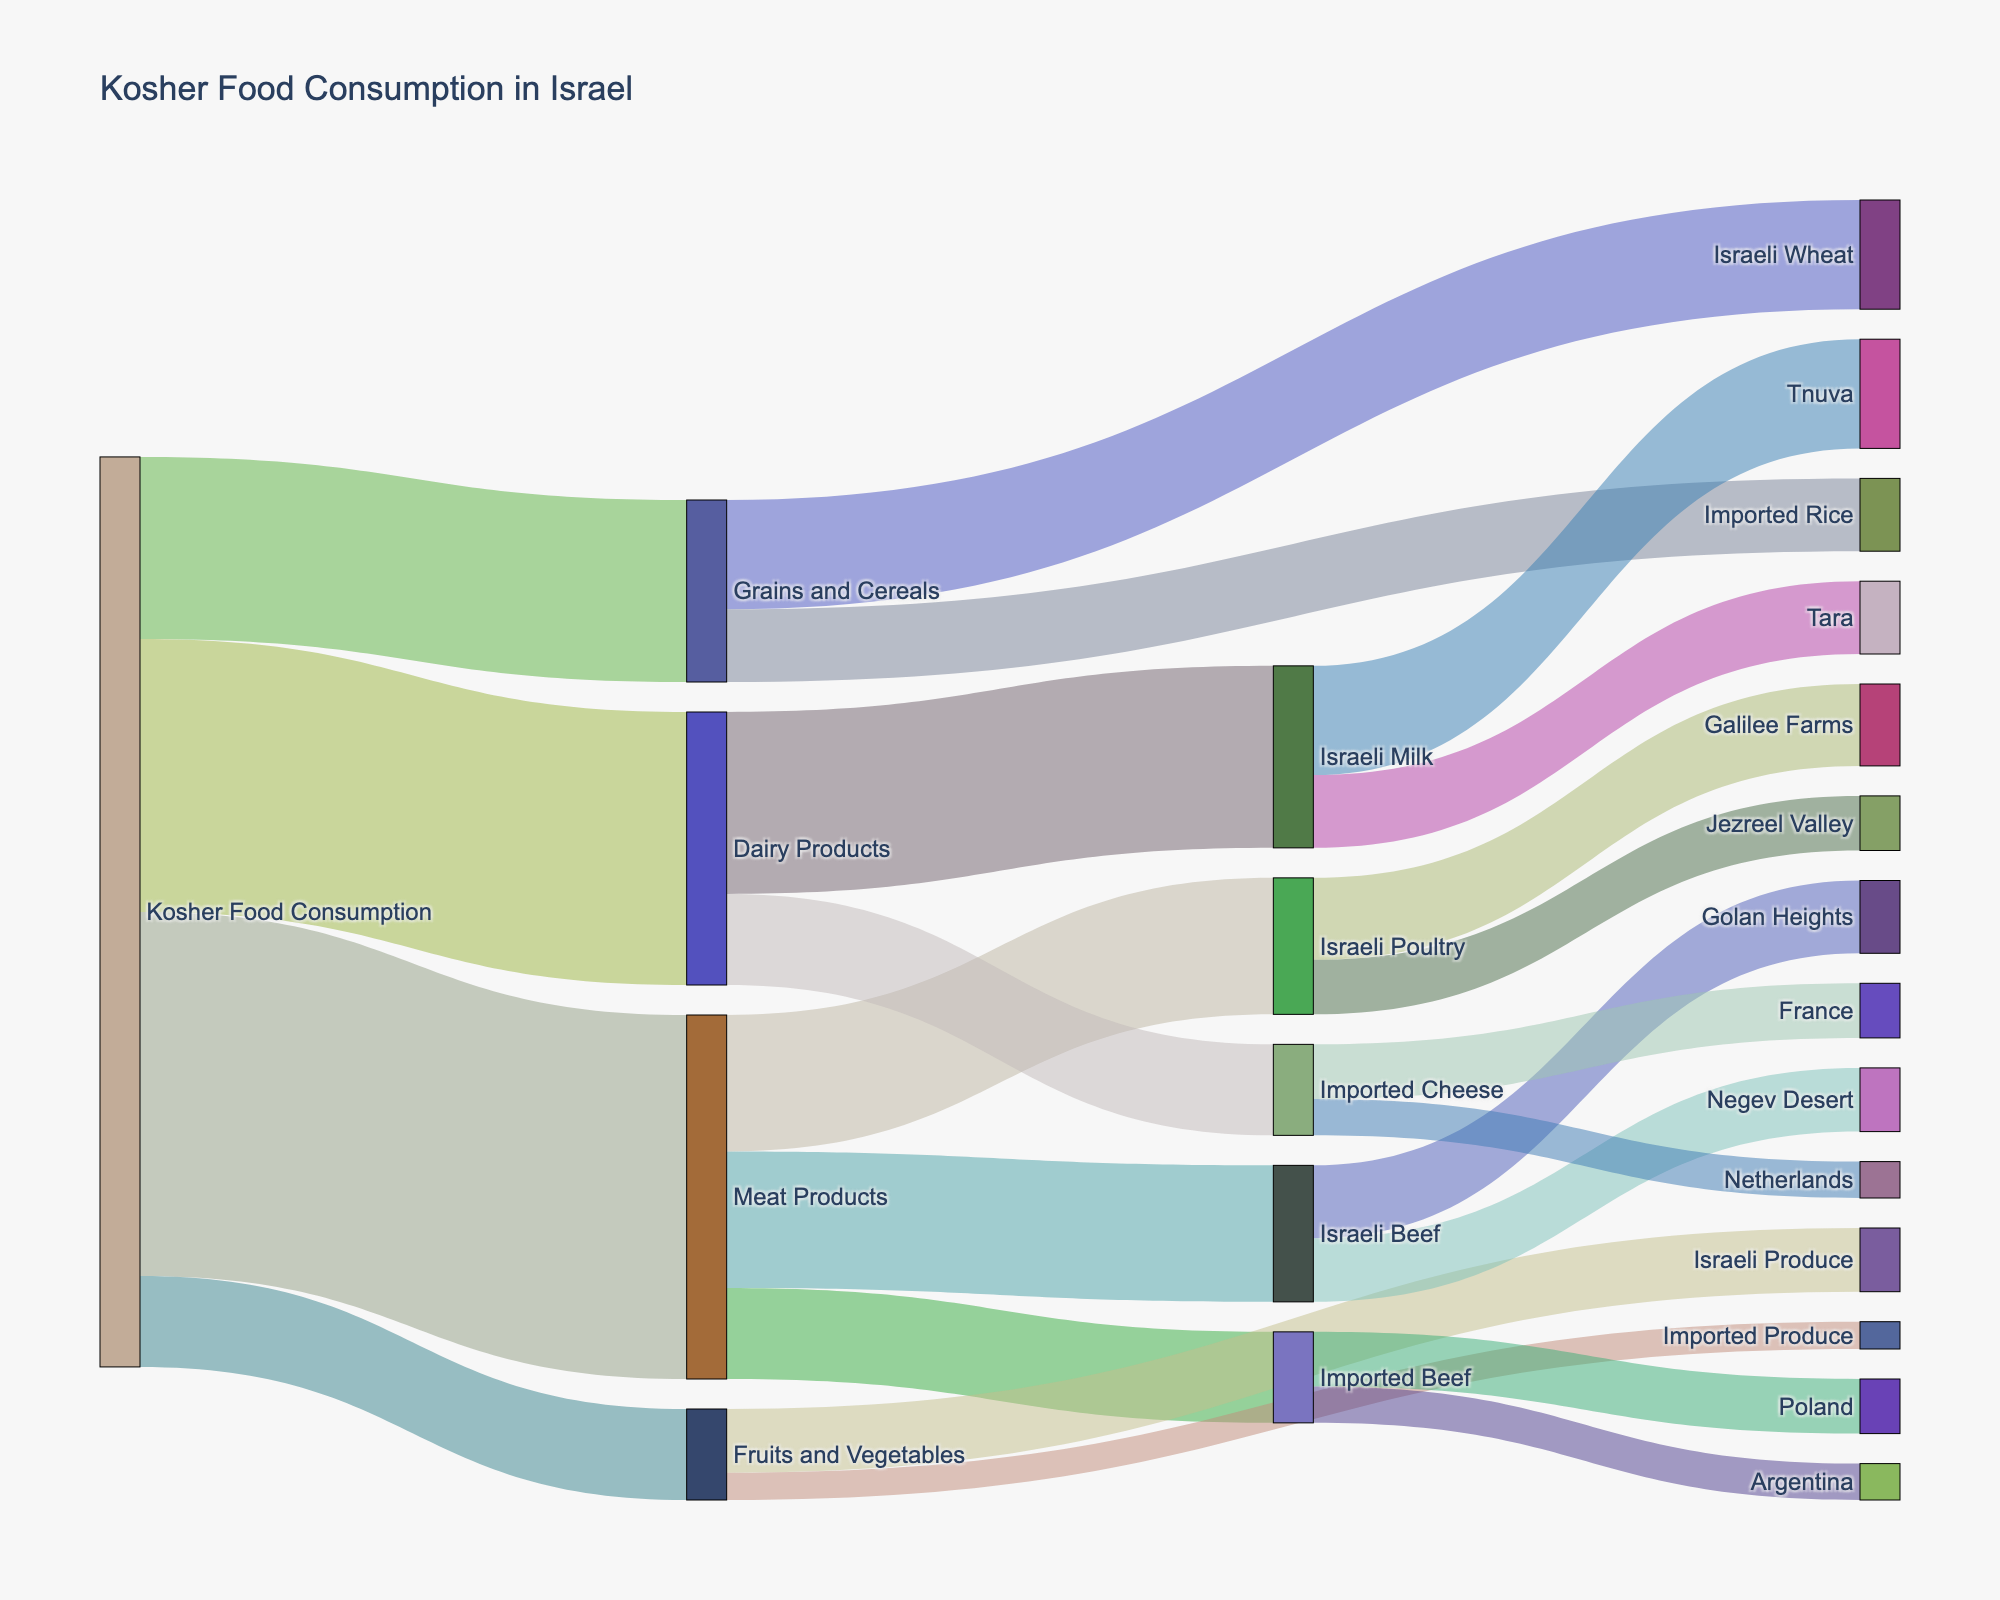How much of the Kosher Food Consumption is represented by Dairy Products? The Kosher Food Consumption segment is divided into several categories, and Dairy Products account for one of these categories. From the figure, Dairy Products are labeled with a value of 30, indicating that they make up a portion of the total Kosher food consumption.
Answer: 30 Which origin of Meat Products has the highest consumption? Meat Products are further divided into Israeli Beef, Imported Beef, and Israeli Poultry. Looking deeper, Israeli Beef, with a value of 15 (distributed further into Golan Heights and Negev Desert), and Israeli Poultry, also valued at 15, show the highest consumption. Hence, both Israeli beef and Israeli poultry have the highest consumption among the Meat Products.
Answer: Israeli Beef, Israeli Poultry What is the total value of Imported Produce in Fruits and Vegetables? Under the Fruits and Vegetables category, the value for Imported Produce is directly given in the figure, listed as 3.
Answer: 3 Compare the total consumption of Israeli Produce to Imported Produce in the Fruits and Vegetables category. In the Fruits and Vegetables category, Israeli Produce is labeled with a value of 7, whereas Imported Produce is marked with a value of 3. Israeli Produce is higher in consumption compared to Imported Produce.
Answer: Israeli Produce > Imported Produce Calculate the combined value of Israeli sources in the Grains and Cereals category. For Grains and Cereals, the subcategories are Israeli Wheat and Imported Rice. Israeli Wheat has a value of 12. Hence, the combined value from Israeli sources in this category is 12.
Answer: 12 Which country contributes more to Imported Beef: Poland or Argentina? Imported Beef is divided between Poland and Argentina. Poland has a value of 6, while Argentina has a value of 4. Therefore, Poland contributes more to Imported Beef.
Answer: Poland What is the overall contribution of Tnuva to Kosher Food Consumption? Tnuva is part of the Dairy Products category under Israeli Milk and has a value of 12. This is the overall contribution of Tnuva to the Kosher Food Consumption.
Answer: 12 How does the consumption of Israeli Wheat compare to the combined consumption of all fruits and vegetables? Israeli Wheat has a value of 12, while the total for Fruits and Vegetables (both Israeli Produce and Imported Produce) is 7 + 3 = 10. Hence, Israeli Wheat consumption is higher.
Answer: Israeli Wheat > All Fruits and Vegetables What is the proportion of the contribution of Imported Cheese to the total Dairy Products? Dairy Products total 30, with Imported Cheese valued at 10. Thus, the proportion is 10/30 = 1/3 or approximately 33.33%.
Answer: 33.33% Which contributes more to Dairy Products, Israeli Milk or Imported Cheese, and by how much? Israeli Milk contributes 20 to Dairy Products, while Imported Cheese contributes 10. The difference is 20 - 10 = 10.
Answer: Israeli Milk, by 10 